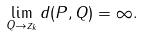Convert formula to latex. <formula><loc_0><loc_0><loc_500><loc_500>\lim _ { Q \to z _ { k } } d ( P , Q ) = \infty .</formula> 